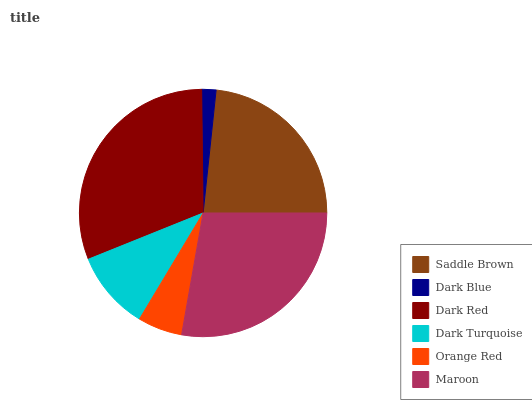Is Dark Blue the minimum?
Answer yes or no. Yes. Is Dark Red the maximum?
Answer yes or no. Yes. Is Dark Red the minimum?
Answer yes or no. No. Is Dark Blue the maximum?
Answer yes or no. No. Is Dark Red greater than Dark Blue?
Answer yes or no. Yes. Is Dark Blue less than Dark Red?
Answer yes or no. Yes. Is Dark Blue greater than Dark Red?
Answer yes or no. No. Is Dark Red less than Dark Blue?
Answer yes or no. No. Is Saddle Brown the high median?
Answer yes or no. Yes. Is Dark Turquoise the low median?
Answer yes or no. Yes. Is Dark Blue the high median?
Answer yes or no. No. Is Maroon the low median?
Answer yes or no. No. 